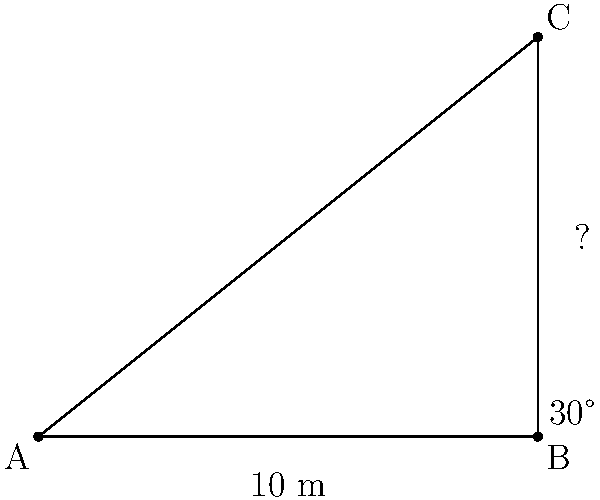During your pole vault practice, you notice a new bar setup. Standing 10 meters away from the base of the pole, you observe that the angle of elevation to the top of the bar is 30°. What is the height of the pole vault bar? To solve this problem, we'll use trigonometry, specifically the tangent function. Here's a step-by-step solution:

1) In a right triangle, tangent of an angle is the ratio of the opposite side to the adjacent side.

2) In this case:
   - The angle of elevation is 30°
   - The adjacent side (distance from you to the base) is 10 meters
   - The opposite side is the height we're looking for

3) Let's call the height $h$. We can write the equation:

   $$\tan(30°) = \frac{h}{10}$$

4) We know that $\tan(30°) = \frac{1}{\sqrt{3}}$, so we can rewrite the equation:

   $$\frac{1}{\sqrt{3}} = \frac{h}{10}$$

5) To solve for $h$, multiply both sides by 10:

   $$\frac{10}{\sqrt{3}} = h$$

6) Simplify:
   
   $$h = 10 \cdot \frac{1}{\sqrt{3}} \approx 5.77$$

Therefore, the height of the pole vault bar is approximately 5.77 meters.
Answer: 5.77 meters 